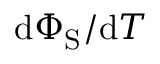<formula> <loc_0><loc_0><loc_500><loc_500>d \Phi _ { S } / d T</formula> 